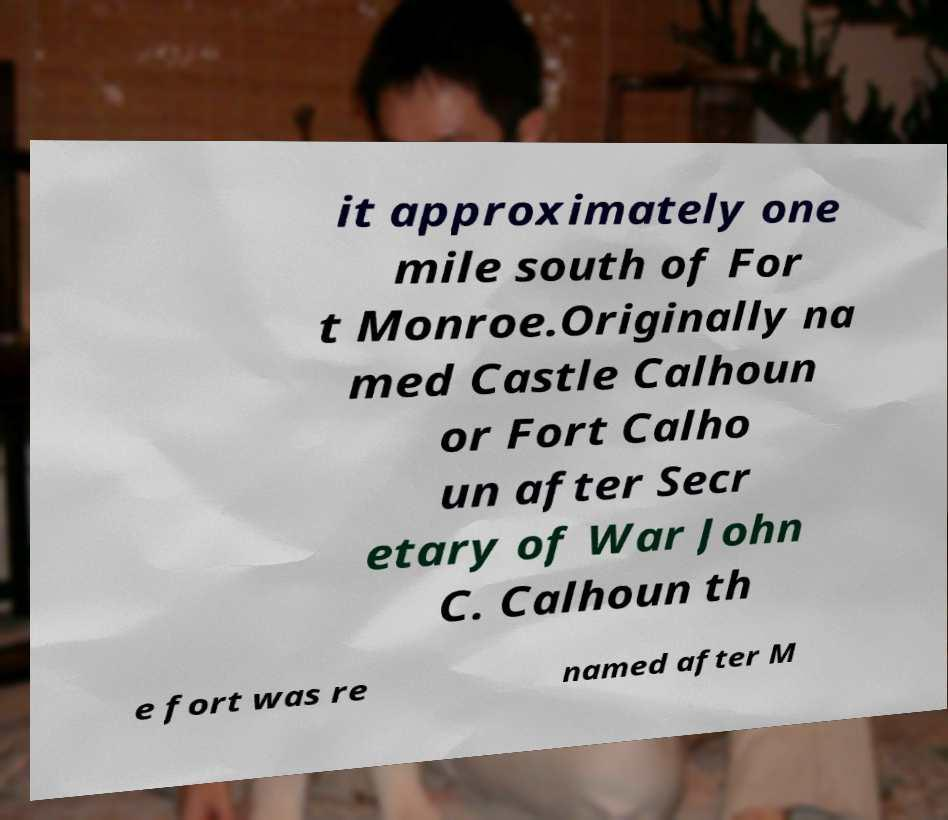There's text embedded in this image that I need extracted. Can you transcribe it verbatim? it approximately one mile south of For t Monroe.Originally na med Castle Calhoun or Fort Calho un after Secr etary of War John C. Calhoun th e fort was re named after M 